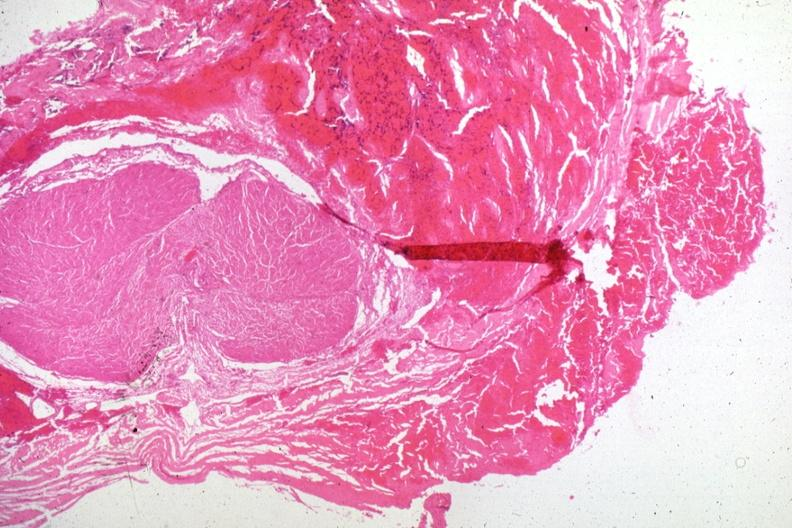what is present?
Answer the question using a single word or phrase. Pituitary 